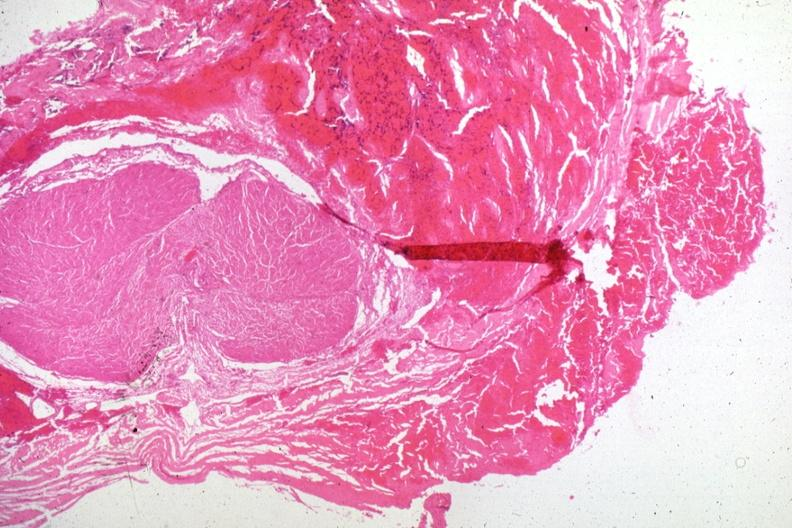what is present?
Answer the question using a single word or phrase. Pituitary 